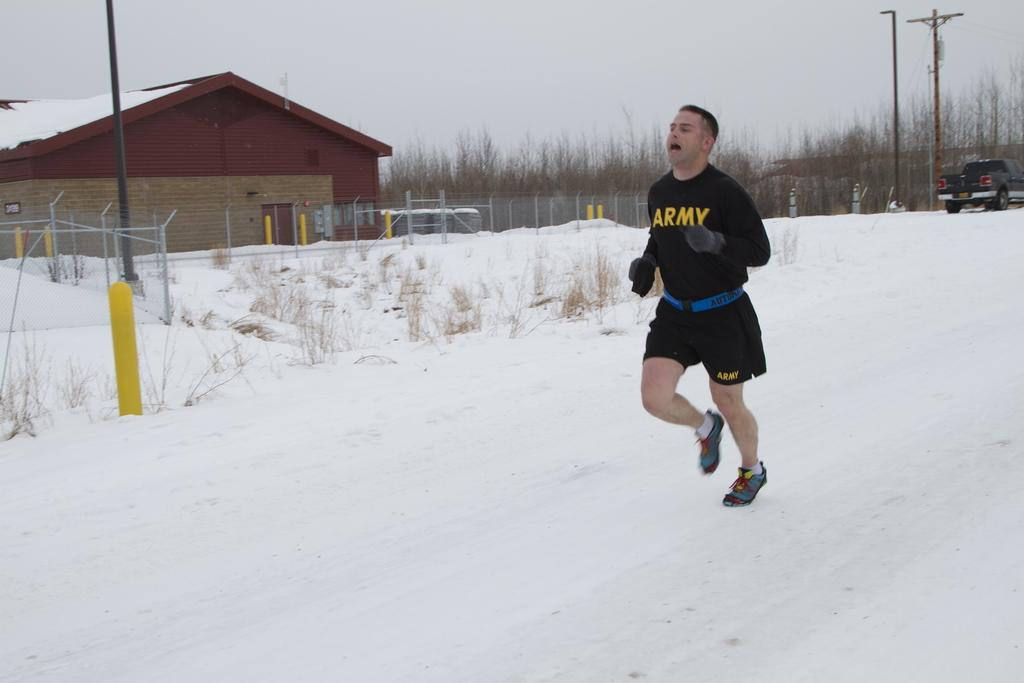<image>
Describe the image concisely. A man wearing black ARMY clothing jogs in the snow. 